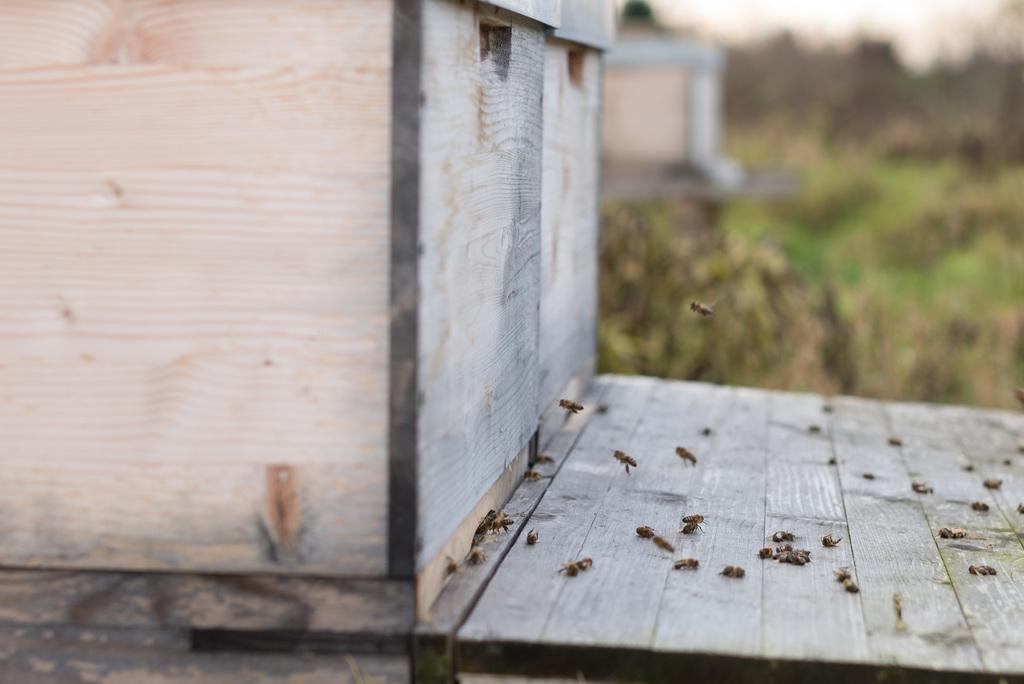What type of insects are present in the image? There are honey bees in the image. What type of structure can be seen in the image? There are wooden boxes in the image. What type of jam is being made in the wooden boxes in the image? There is no jam-making process depicted in the image; it only shows honey bees and wooden boxes. Can you see the moon in the image? The moon is not visible in the image; it only features honey bees and wooden boxes. 